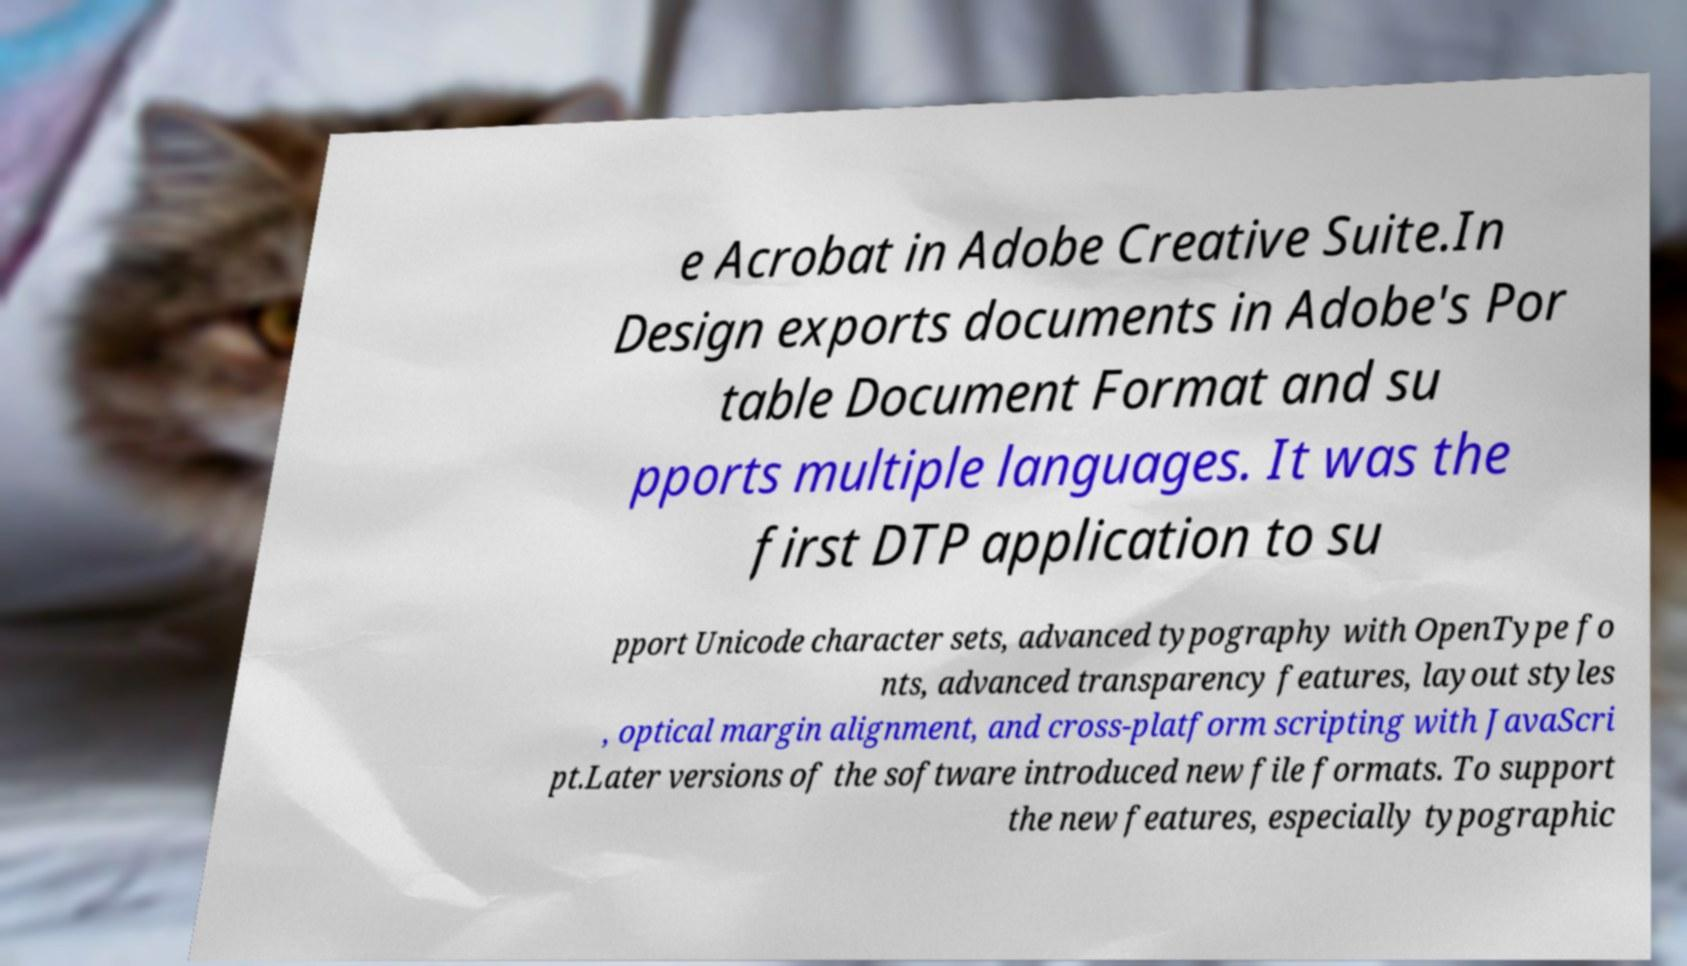Please read and relay the text visible in this image. What does it say? e Acrobat in Adobe Creative Suite.In Design exports documents in Adobe's Por table Document Format and su pports multiple languages. It was the first DTP application to su pport Unicode character sets, advanced typography with OpenType fo nts, advanced transparency features, layout styles , optical margin alignment, and cross-platform scripting with JavaScri pt.Later versions of the software introduced new file formats. To support the new features, especially typographic 